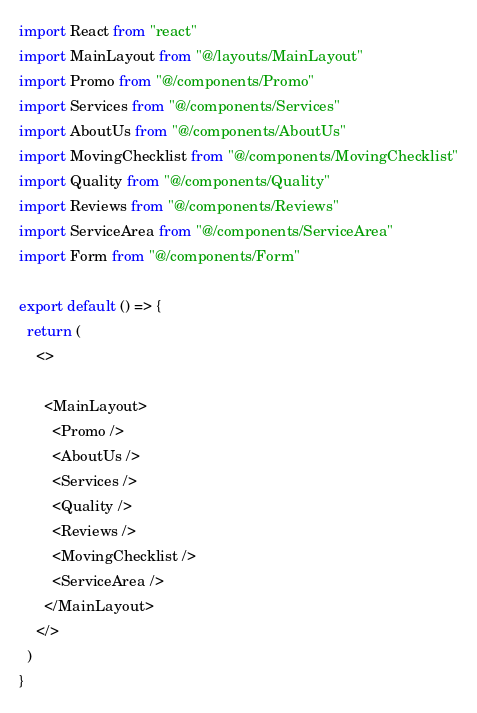Convert code to text. <code><loc_0><loc_0><loc_500><loc_500><_JavaScript_>import React from "react"
import MainLayout from "@/layouts/MainLayout"
import Promo from "@/components/Promo"
import Services from "@/components/Services"
import AboutUs from "@/components/AboutUs"
import MovingChecklist from "@/components/MovingChecklist"
import Quality from "@/components/Quality"
import Reviews from "@/components/Reviews"
import ServiceArea from "@/components/ServiceArea"
import Form from "@/components/Form"

export default () => {
  return (
    <>
    
      <MainLayout>
        <Promo />
        <AboutUs />
        <Services />
        <Quality />
        <Reviews />
        <MovingChecklist />
        <ServiceArea />
      </MainLayout>
    </>
  )
}
</code> 